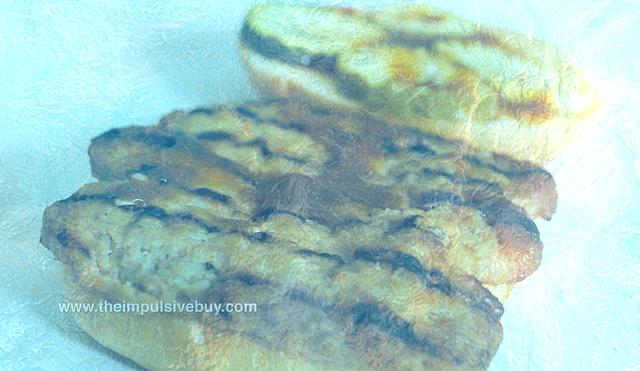Can you describe the texture and possible flavor of this bread based on its appearance? From its golden-brown exterior, one can infer a toasty crust with a satisfying crunch. The interior likely has a soft, warm texture. Its flavor might hold the hearty, yeasty notes characteristic of freshly baked bread, perhaps with a slight hint of sweetness that typically accompanies a well-caramelized crust. 